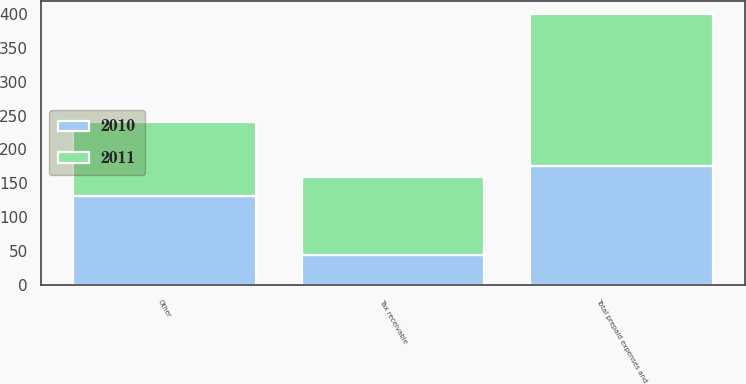Convert chart to OTSL. <chart><loc_0><loc_0><loc_500><loc_500><stacked_bar_chart><ecel><fcel>Tax receivable<fcel>Other<fcel>Total prepaid expenses and<nl><fcel>2010<fcel>44<fcel>131<fcel>175<nl><fcel>2011<fcel>116<fcel>109<fcel>225<nl></chart> 